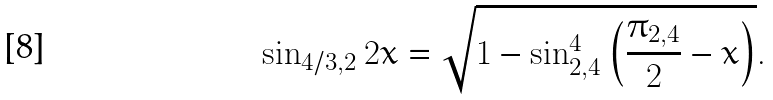<formula> <loc_0><loc_0><loc_500><loc_500>\sin _ { 4 / 3 , 2 } { 2 x } = \sqrt { 1 - \sin _ { 2 , 4 } ^ { 4 } { \left ( \frac { \pi _ { 2 , 4 } } { 2 } - x \right ) } } .</formula> 